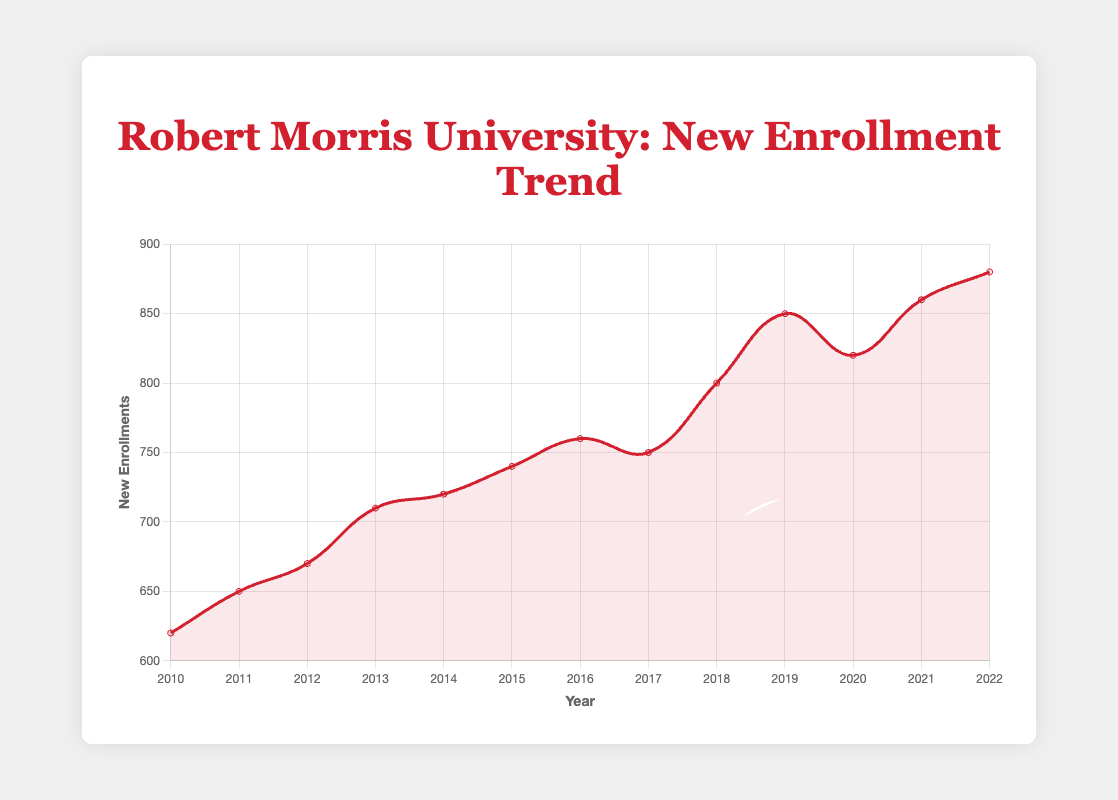What is the general trend in new enrollments at Robert Morris University from 2010 to 2022? The line chart showing new enrollments at Robert Morris University from 2010 to 2022 exhibits an overall upward trend with minor fluctuations. The data points generally increase over the years, indicating a rise in new enrollments.
Answer: Upward trend Which year experienced the highest number of new enrollments? The line chart peaks at the point labeled 2022 with the enrollment number reaching 880, which is the highest on the chart.
Answer: 2022 In which year did new enrollments see a decrease compared to the previous year? Looking at the chart, new enrollments decreased from 2017 to 2018, from 760 to 750, and from 2019 to 2020, from 850 to 820.
Answer: 2017 to 2018 and 2019 to 2020 What is the difference in new enrollments between the years 2010 and 2022? The new enrollments in 2010 are 620, and in 2022 they are 880. The difference is calculated as 880 - 620.
Answer: 260 On average, how many new enrollments were there per year from 2010 to 2022? To find the average, sum all the new enrollments from 2010 to 2022 and then divide by the number of years (13). The sum is 620 + 650 + 670 + 710 + 720 + 740 + 760 + 750 + 800 + 850 + 820 + 860 + 880 = 9830. The average is 9830 / 13.
Answer: 756.15 Which year saw the smallest increase in new enrollments compared to the previous year? By examining the differences between consecutive years, 2013 to 2014 shows the smallest increase, from 710 to 720, which is an increase of 10.
Answer: 2014 How did new enrollments change from 2015 to 2016? The chart shows an increase in new enrollments from 740 in 2015 to 760 in 2016.
Answer: Increased What is the overall percent increase in new enrollments from 2010 to 2022? First, calculate the difference: 880 (2022) - 620 (2010) = 260. Then divide the difference by the initial value (620) and multiply by 100 to get the percentage: (260 / 620) * 100.
Answer: 41.94% Between which consecutive years did new enrollments remain almost constant and what were those values? Between 2017 and 2018, new enrollments remained almost constant with the values 750 and 750.
Answer: 2017 and 2018, 750 How many years saw new enrollments rise above 800? By examining the chart, the years 2018, 2019, 2020, 2021, and 2022 all have enrollments above 800. This makes it 5 years.
Answer: 5 